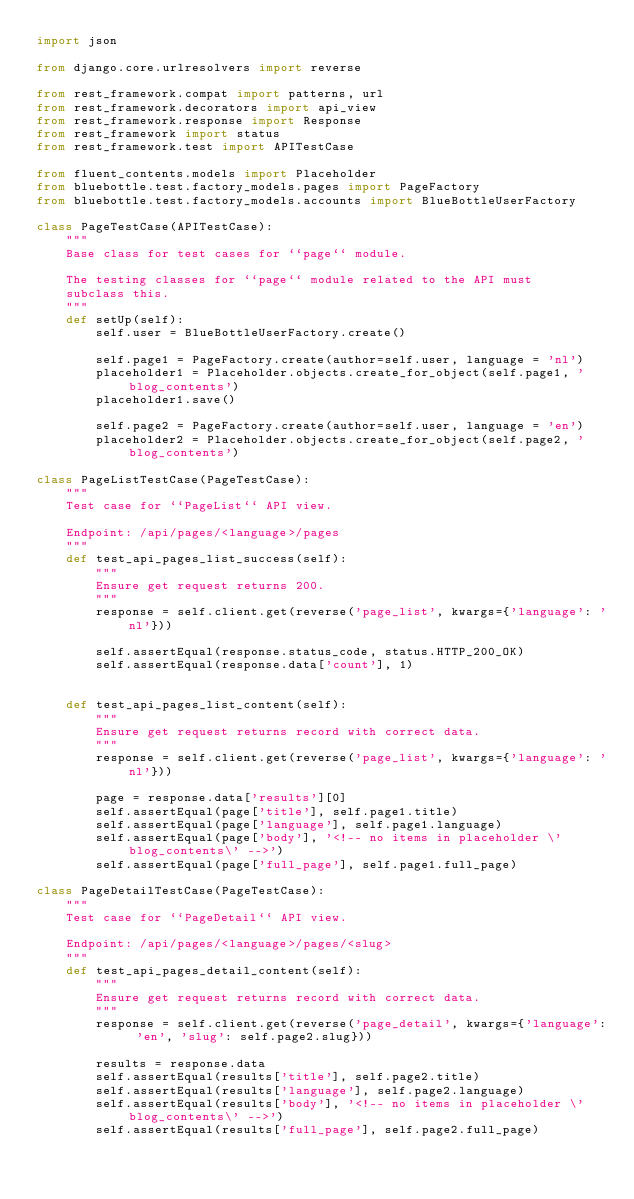Convert code to text. <code><loc_0><loc_0><loc_500><loc_500><_Python_>import json

from django.core.urlresolvers import reverse

from rest_framework.compat import patterns, url
from rest_framework.decorators import api_view
from rest_framework.response import Response
from rest_framework import status
from rest_framework.test import APITestCase

from fluent_contents.models import Placeholder
from bluebottle.test.factory_models.pages import PageFactory
from bluebottle.test.factory_models.accounts import BlueBottleUserFactory

class PageTestCase(APITestCase):
	"""
	Base class for test cases for ``page`` module.

	The testing classes for ``page`` module related to the API must
	subclass this.
	"""
	def setUp(self):
		self.user = BlueBottleUserFactory.create()

		self.page1 = PageFactory.create(author=self.user, language = 'nl')
		placeholder1 = Placeholder.objects.create_for_object(self.page1, 'blog_contents')
		placeholder1.save()

		self.page2 = PageFactory.create(author=self.user, language = 'en')
		placeholder2 = Placeholder.objects.create_for_object(self.page2, 'blog_contents')

class PageListTestCase(PageTestCase):
	"""
	Test case for ``PageList`` API view.

	Endpoint: /api/pages/<language>/pages
	"""
	def test_api_pages_list_success(self):
		"""
		Ensure get request returns 200.
		"""
		response = self.client.get(reverse('page_list', kwargs={'language': 'nl'}))

		self.assertEqual(response.status_code, status.HTTP_200_OK)
		self.assertEqual(response.data['count'], 1)


	def test_api_pages_list_content(self):
		"""
		Ensure get request returns record with correct data.
		"""
		response = self.client.get(reverse('page_list', kwargs={'language': 'nl'}))

		page = response.data['results'][0]
		self.assertEqual(page['title'], self.page1.title)
		self.assertEqual(page['language'], self.page1.language)
		self.assertEqual(page['body'], '<!-- no items in placeholder \'blog_contents\' -->')
		self.assertEqual(page['full_page'], self.page1.full_page)

class PageDetailTestCase(PageTestCase):
	"""
	Test case for ``PageDetail`` API view.

	Endpoint: /api/pages/<language>/pages/<slug>
	"""
	def test_api_pages_detail_content(self):
		"""
		Ensure get request returns record with correct data.
		"""
		response = self.client.get(reverse('page_detail', kwargs={'language': 'en', 'slug': self.page2.slug}))

		results = response.data
		self.assertEqual(results['title'], self.page2.title)
		self.assertEqual(results['language'], self.page2.language)
		self.assertEqual(results['body'], '<!-- no items in placeholder \'blog_contents\' -->')
		self.assertEqual(results['full_page'], self.page2.full_page)</code> 